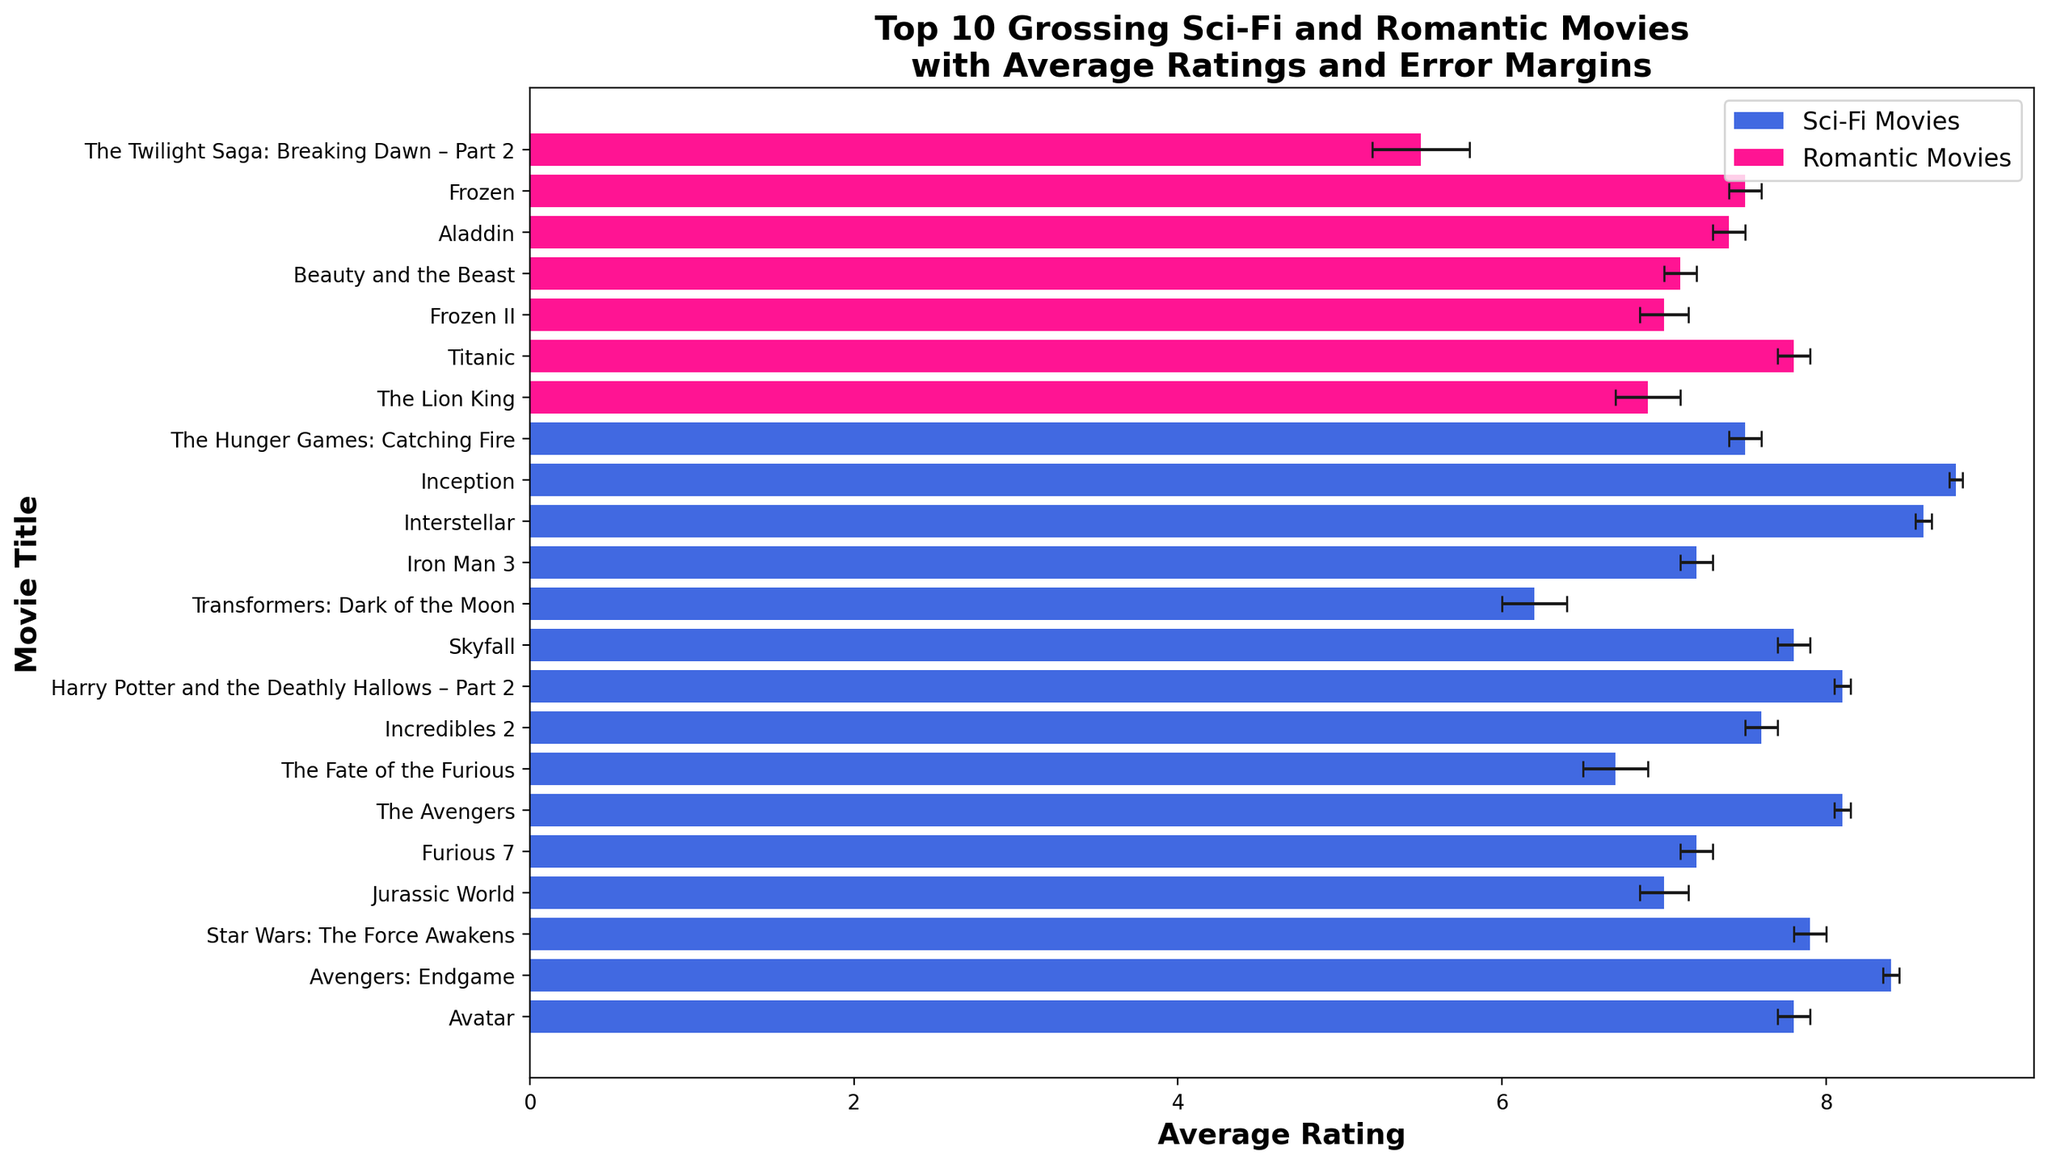Which Sci-Fi movie has the highest average rating? To identify the Sci-Fi movie with the highest average rating, we inspect the blue bars for Sci-Fi movies. Among them, "Inception" has the highest rating at 8.8.
Answer: Inception Which Romantic movie has the largest error margin? To find the Romantic movie with the largest error margin, we look at the error bars on the pink bars for Romantic movies. "The Twilight Saga: Breaking Dawn – Part 2" has the largest error margin at 0.3.
Answer: The Twilight Saga: Breaking Dawn – Part 2 What is the difference in average rating between "Avatar" and "Avengers: Endgame"? Subtract the average rating of "Avatar" (7.8) from that of "Avengers: Endgame" (8.4) to find the difference, 8.4 - 7.8.
Answer: 0.6 Which movie has the lowest average rating overall? By checking both blue (Sci-Fi) and pink (Romantic) bars, "The Twilight Saga: Breaking Dawn – Part 2" has the lowest average rating at 5.5.
Answer: The Twilight Saga: Breaking Dawn – Part 2 Are there any movies with the same average rating? If so, which ones? We compare the average ratings of the movies visually; "Avatar", "Titanic", and "Skyfall" all have an average rating of 7.8.
Answer: Avatar, Titanic, Skyfall How many Sci-Fi movies have an average rating above 8.0? To determine this, count the Sci-Fi movies (blue bars) that have an average rating above 8.0. They are "Avengers: Endgame", "The Avengers", "Harry Potter and the Deathly Hallows – Part 2", "Interstellar", and "Inception".
Answer: 5 What is the range of average ratings for Romantic movies? To find the range, subtract the lowest average rating (5.5 for "The Twilight Saga: Breaking Dawn – Part 2") from the highest average rating (7.8 for "Titanic"). The range is 7.8 - 5.5.
Answer: 2.3 Which category has a higher average rating on the whole, Sci-Fi or Romantic? Average the ratings of all Sci-Fi and Romantic movies independently, compare the two averages. The Sci-Fi category generally has higher ratings with several movies above 8, while the highest-rated Romantic movie is "Titanic" at 7.8.
Answer: Sci-Fi How does the error margin of "Jurassic World" compare to that of "Frozen II"? "Jurassic World" has an error margin of 0.15, whereas "Frozen II" also has an error margin of 0.15. Therefore, their error margins are equal.
Answer: Equal What is the sum of the average ratings for all movies? Sum the average ratings of all 20 movies, adding them up: 7.8 + 8.4 + 7.9 + 7.0 + 6.9 + 7.8 + 7.2 + 8.1 + 6.7 + 7.6 + 7.0 + 7.1 + 8.1 + 7.4 + 7.8 + 6.2 + 7.2 + 7.5 + 5.5 + 8.6 + 8.8 + 7.5. The result is 161.1.
Answer: 161.1 